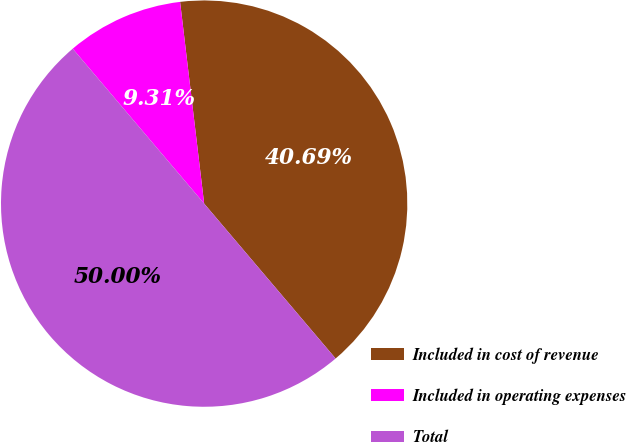Convert chart to OTSL. <chart><loc_0><loc_0><loc_500><loc_500><pie_chart><fcel>Included in cost of revenue<fcel>Included in operating expenses<fcel>Total<nl><fcel>40.69%<fcel>9.31%<fcel>50.0%<nl></chart> 